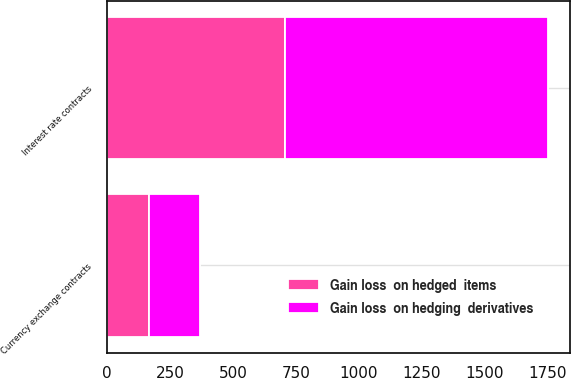Convert chart to OTSL. <chart><loc_0><loc_0><loc_500><loc_500><stacked_bar_chart><ecel><fcel>Interest rate contracts<fcel>Currency exchange contracts<nl><fcel>Gain loss  on hedged  items<fcel>708<fcel>169<nl><fcel>Gain loss  on hedging  derivatives<fcel>1041<fcel>199<nl></chart> 